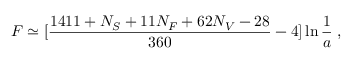Convert formula to latex. <formula><loc_0><loc_0><loc_500><loc_500>F \simeq [ { \frac { 1 4 1 1 + N _ { S } + 1 1 N _ { F } + 6 2 N _ { V } - 2 8 } { 3 6 0 } } - 4 ] \ln { { \frac { 1 } { a } } } \, ,</formula> 